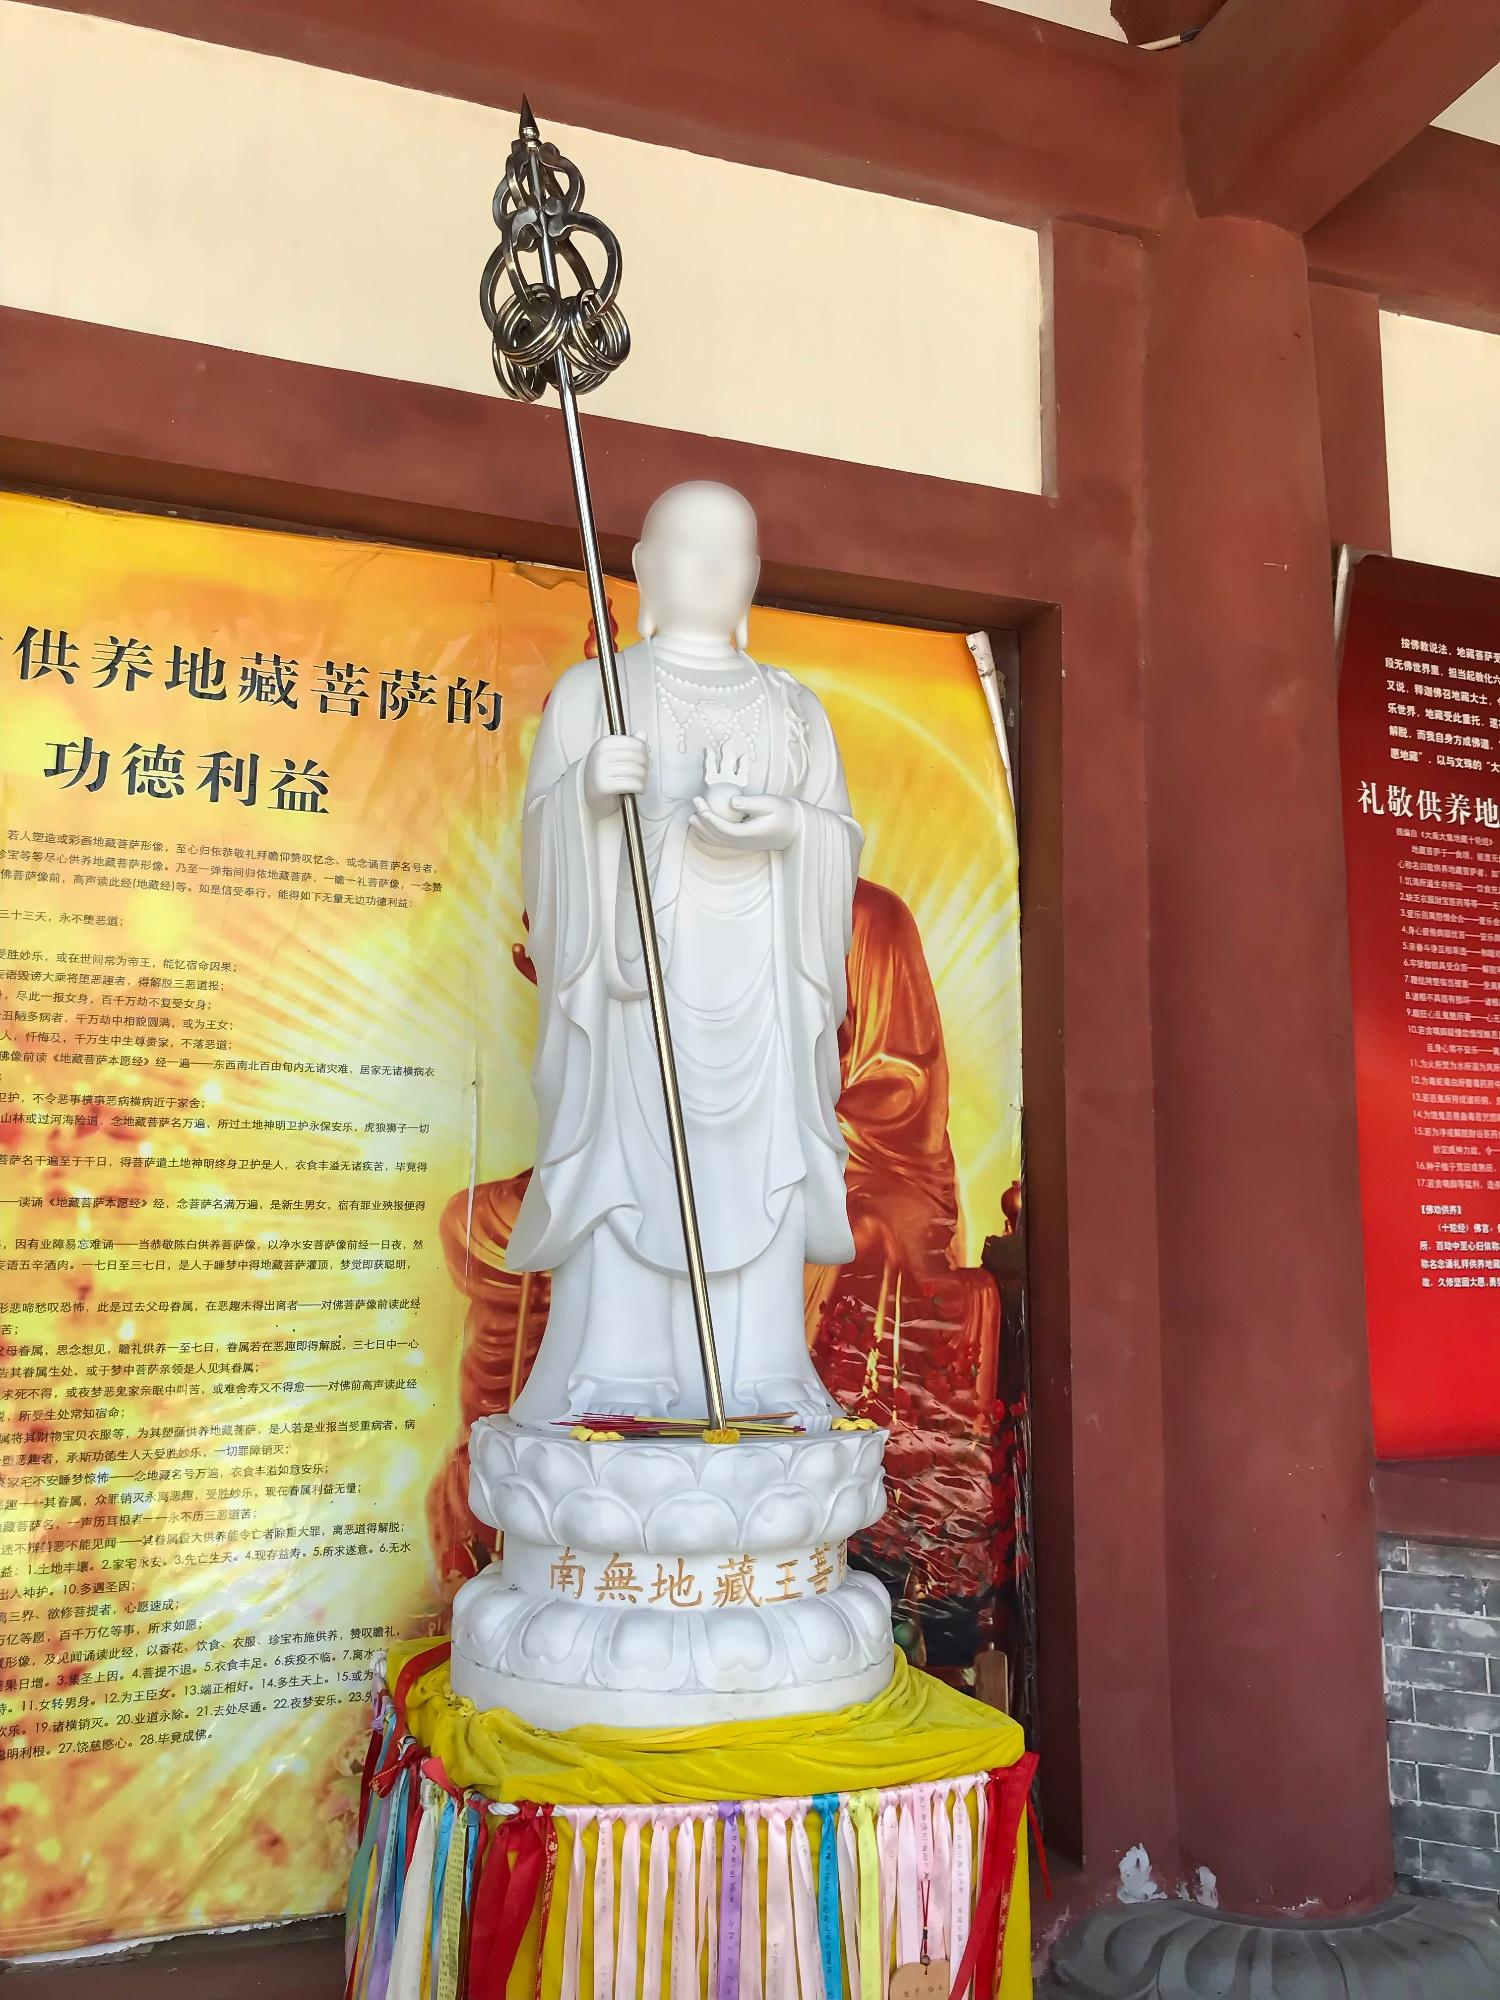Can you tell me more about the staff that the figure is holding? Certainly! The staff held by the figure is usually symbolic in Buddhist art. It may represent authority or the high status of the figure within the monastic community. In some traditions, staffs are also seen as a symbol of asceticism, representing the monk's life of simplicity and detachment from material possessions. The presence of the lotus flower at the top of the staff is especially significant, as the lotus is a powerful symbol in Buddhism, denoting purity, enlightenment, and rebirth, since it grows in muddy water but blooms untainted above it. 